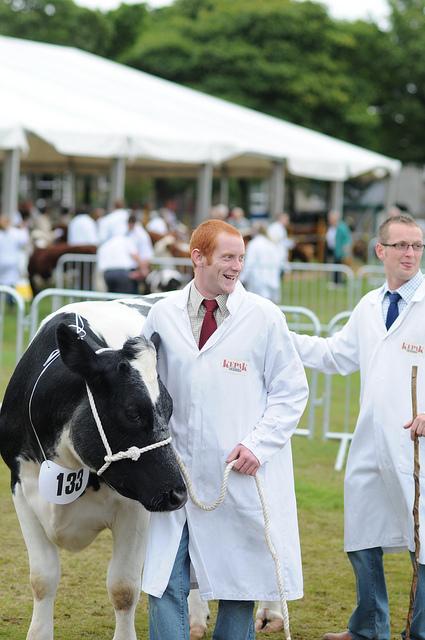What is hair color of the man without the glasses?
Short answer required. Red. Are they wearing lab coats?
Keep it brief. Yes. What is the cow's number?
Keep it brief. 133. 